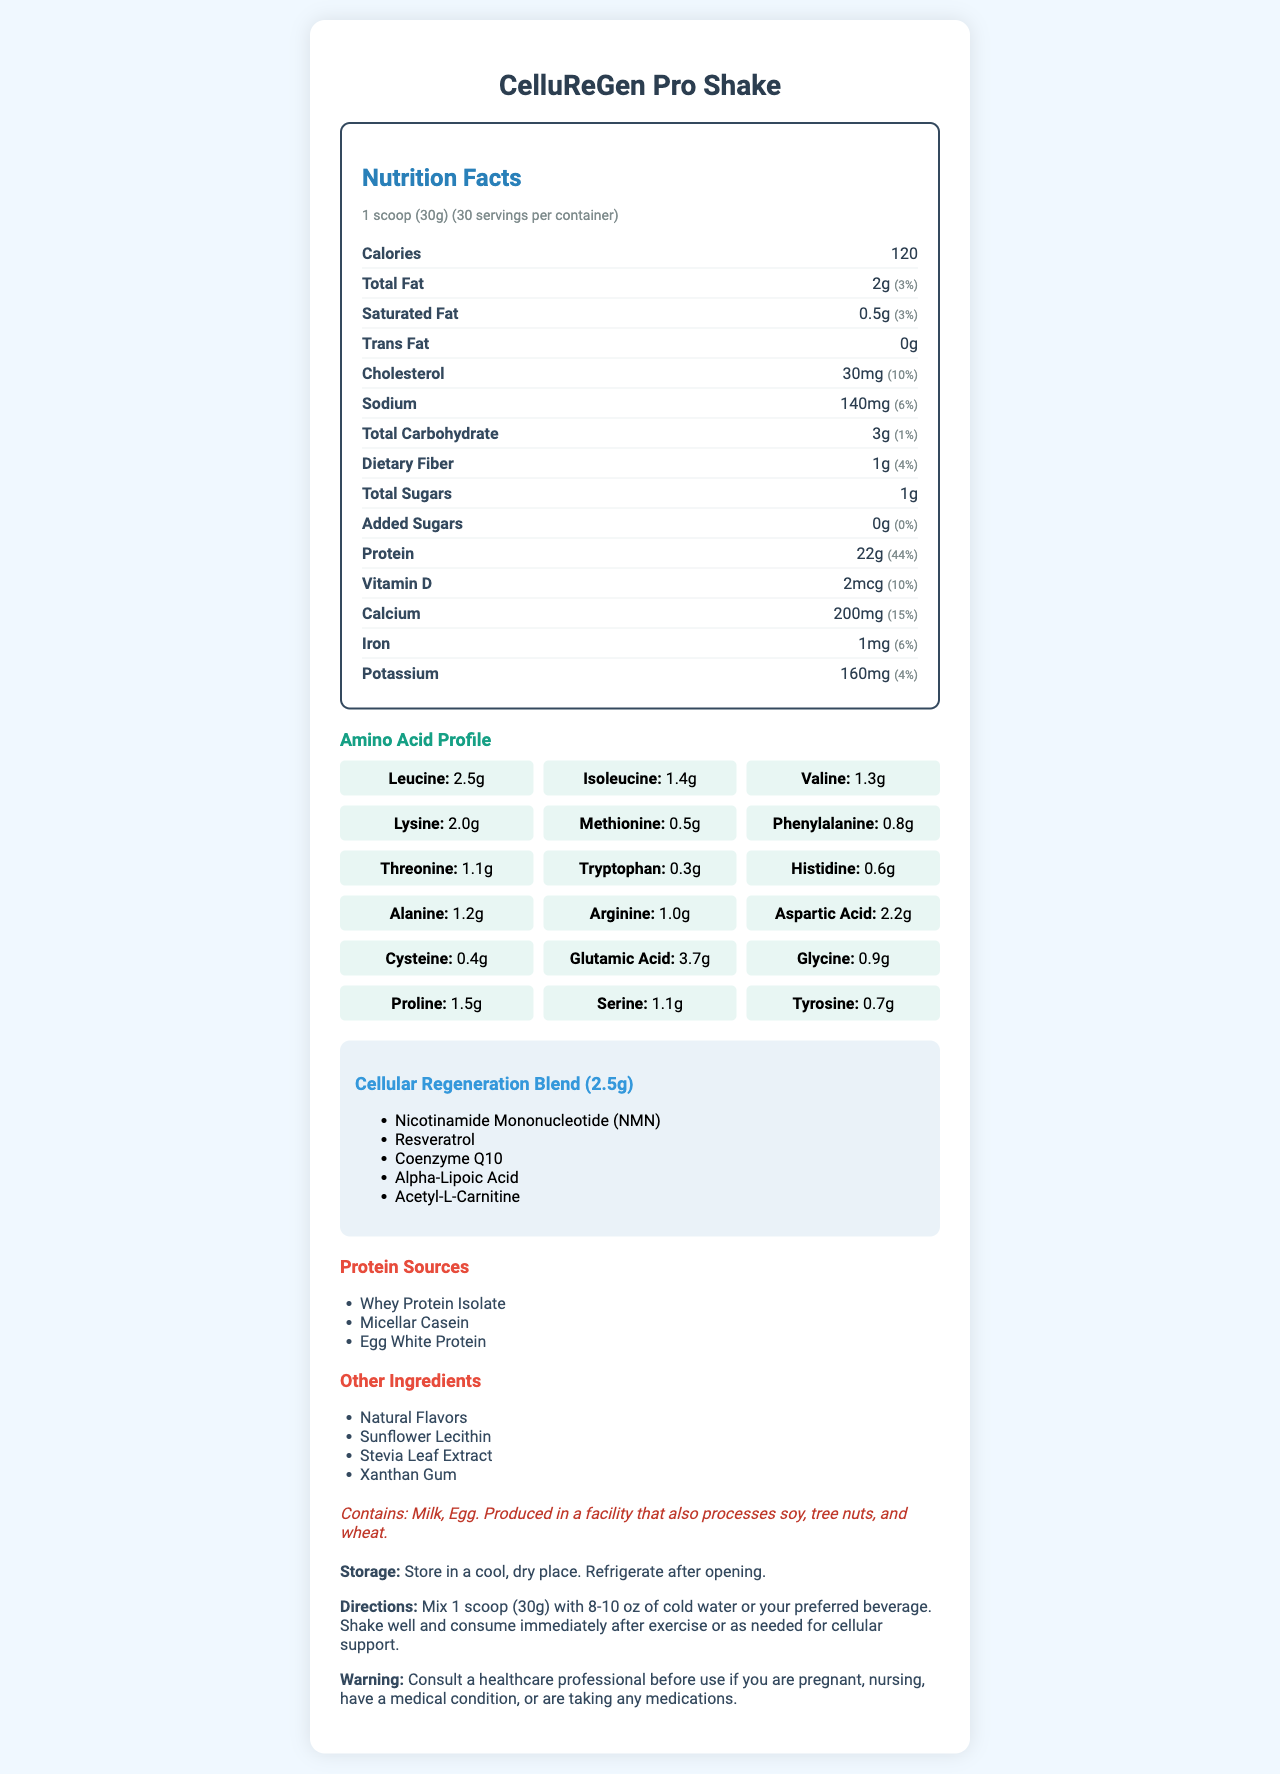what is the serving size of CelluReGen Pro Shake? According to the document, the serving size is explicitly mentioned as "1 scoop (30g)".
Answer: 1 scoop (30g) how many servings are in one container? The document states that there are 30 servings per container.
Answer: 30 how many calories are in one serving? The document highlights that each serving contains 120 calories.
Answer: 120 what is the amount of protein in one serving? The amount of protein per serving is listed as 22g.
Answer: 22g name two amino acids found in CelluReGen Pro Shake. Leucine and Isoleucine are part of the amino acid profile provided in the document.
Answer: Leucine, Isoleucine what is the main purpose of the Cellular Regeneration Blend? The name "Cellular Regeneration Blend" and its inclusion in a protein shake designed to support cellular regeneration suggests this purpose.
Answer: to support cellular regeneration does the product contain any added sugars? Yes or No. The document shows that the amount of added sugars is "0g", indicating no added sugars.
Answer: No which of the following is NOT an ingredient in the Cellular Regeneration Blend? A. Nicotinamide Mononucleotide B. Resveratrol C. Whey Protein Isolate D. Alpha-Lipoic Acid Whey Protein Isolate is listed under protein sources, not in the Cellular Regeneration Blend.
Answer: C. Whey Protein Isolate what are the storage instructions for the product? The document clearly states these storage instructions towards the end.
Answer: Store in a cool, dry place. Refrigerate after opening. which nutrient has the highest daily value percentage? A. Protein B. Cholesterol C. Calcium D. Vitamin D The document shows that protein has a daily value percentage of 44%, which is higher than the other options.
Answer: A. Protein what are the allergen warnings for this product? The allergen information section in the document lists these warnings.
Answer: Contains: Milk, Egg. Produced in a facility that also processes soy, tree nuts, and wheat. what are the amino acid amounts for alanine and lysine? The amino acid profile table shows these specific amounts for alanine and lysine.
Answer: Alanine: 1.2g, Lysine: 2.0g how many milligrams of calcium does one serving contain? The document lists the amount of calcium per serving as 200mg.
Answer: 200mg is CelluReGen Pro Shake safe for pregnant women? The warning section advises consulting a healthcare professional if pregnant, but does not definitively say it's safe or unsafe.
Answer: Consult a healthcare professional before use if you are pregnant. summarize the main ingredients and purpose of CelluReGen Pro Shake. This summary pulls together the purposes and key ingredients listed in various parts of the document.
Answer: CelluReGen Pro Shake is a protein shake designed to support cellular regeneration, containing essential amino acids, a Cellular Regeneration Blend with NMN, Resveratrol, Coenzyme Q10, Alpha-Lipoic Acid, and Acetyl-L-Carnitine, and sources such as Whey Protein Isolate, Micellar Casein, and Egg White Protein. how much vitamin D is in each serving? The document specifies that each serving contains 2mcg of vitamin D.
Answer: 2mcg who should be consulted before using this product? The warning section specifically advises consulting a healthcare professional before use if there are any concerns.
Answer: A healthcare professional what alternative artificial sweeteners are included in the product? The only sweetener listed in the "other ingredients" is Stevia Leaf Extract, which is a natural sweetener.
Answer: None cannot determine the flavor of the CelluReGen Pro Shake from the document. The document mentions "Natural Flavors" but does not specify the actual flavor profile.
Answer: Not enough information 